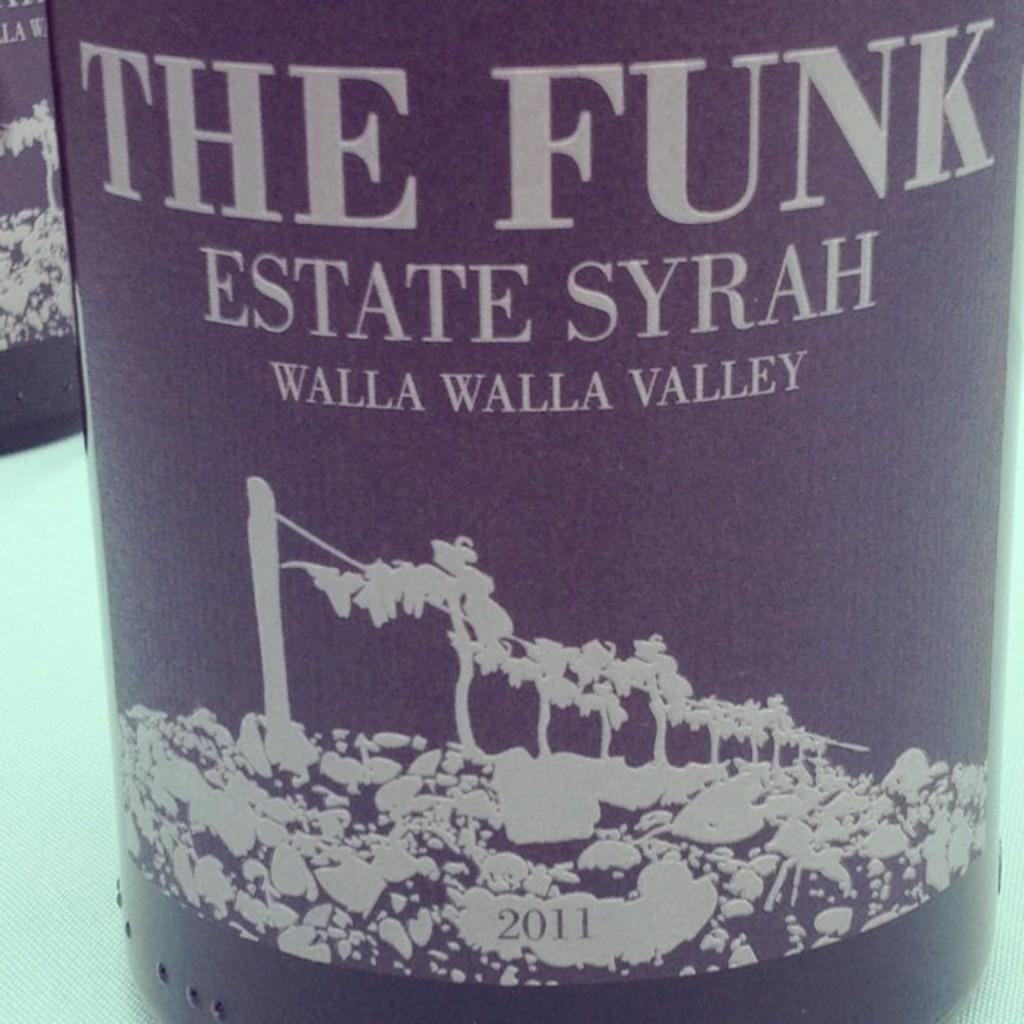Provide a one-sentence caption for the provided image. A bottle of The Funk Estate Syrah wine with a vineyard on the label. 